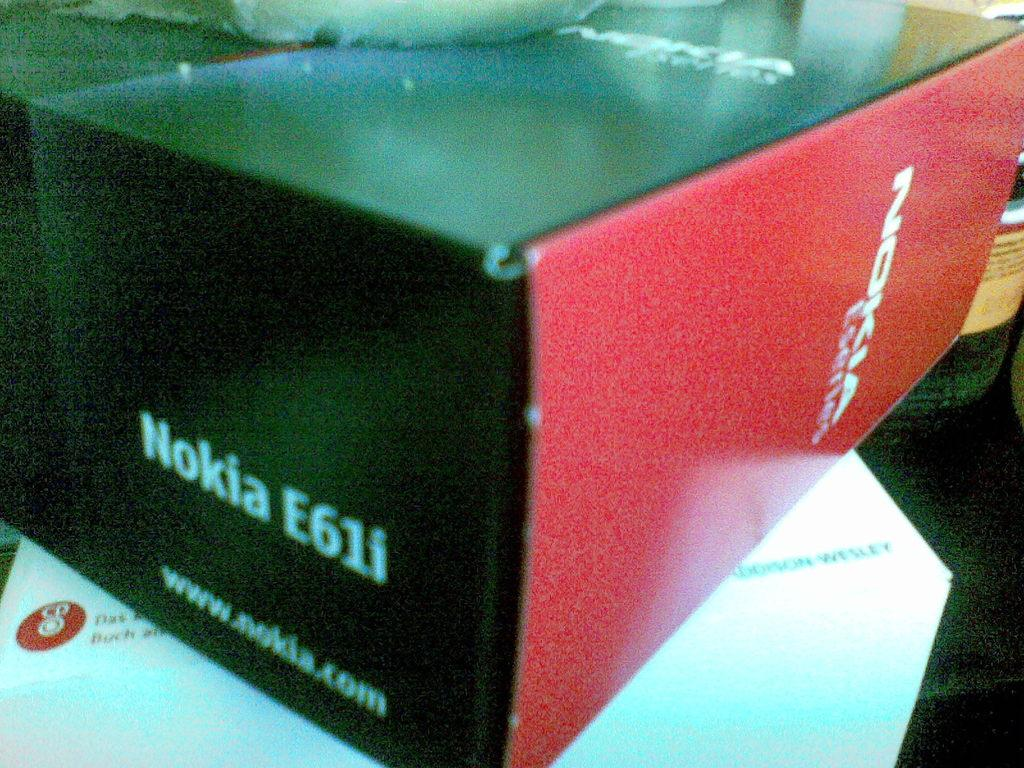<image>
Provide a brief description of the given image. Nokia E61i is the model number shown on the side of this box. 